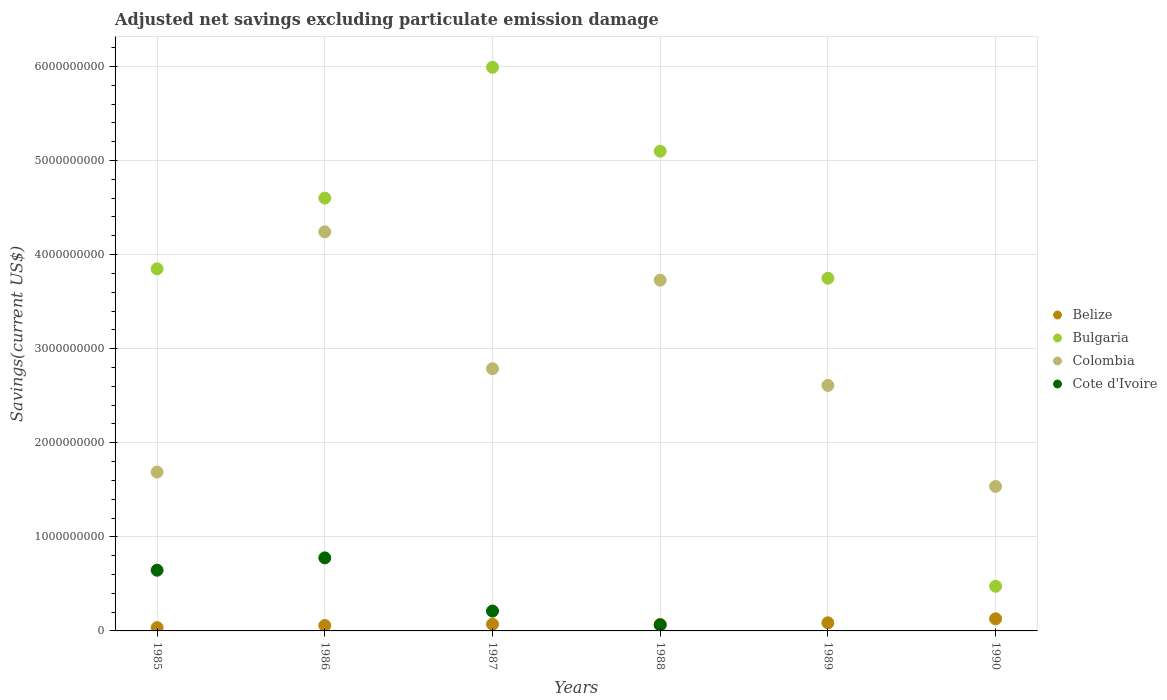How many different coloured dotlines are there?
Keep it short and to the point. 4. Is the number of dotlines equal to the number of legend labels?
Provide a short and direct response. No. What is the adjusted net savings in Belize in 1985?
Provide a succinct answer. 3.48e+07. Across all years, what is the maximum adjusted net savings in Belize?
Provide a short and direct response. 1.29e+08. Across all years, what is the minimum adjusted net savings in Colombia?
Make the answer very short. 1.54e+09. What is the total adjusted net savings in Bulgaria in the graph?
Make the answer very short. 2.38e+1. What is the difference between the adjusted net savings in Cote d'Ivoire in 1986 and that in 1988?
Offer a very short reply. 7.13e+08. What is the difference between the adjusted net savings in Cote d'Ivoire in 1985 and the adjusted net savings in Belize in 1987?
Offer a very short reply. 5.74e+08. What is the average adjusted net savings in Bulgaria per year?
Offer a very short reply. 3.96e+09. In the year 1987, what is the difference between the adjusted net savings in Colombia and adjusted net savings in Belize?
Your answer should be very brief. 2.72e+09. What is the ratio of the adjusted net savings in Belize in 1987 to that in 1989?
Your response must be concise. 0.83. Is the difference between the adjusted net savings in Colombia in 1987 and 1990 greater than the difference between the adjusted net savings in Belize in 1987 and 1990?
Give a very brief answer. Yes. What is the difference between the highest and the second highest adjusted net savings in Bulgaria?
Your response must be concise. 8.91e+08. What is the difference between the highest and the lowest adjusted net savings in Belize?
Provide a succinct answer. 9.39e+07. Is the sum of the adjusted net savings in Colombia in 1985 and 1987 greater than the maximum adjusted net savings in Bulgaria across all years?
Provide a succinct answer. No. Is it the case that in every year, the sum of the adjusted net savings in Colombia and adjusted net savings in Belize  is greater than the sum of adjusted net savings in Bulgaria and adjusted net savings in Cote d'Ivoire?
Offer a very short reply. Yes. Is the adjusted net savings in Cote d'Ivoire strictly greater than the adjusted net savings in Belize over the years?
Offer a very short reply. No. Is the adjusted net savings in Cote d'Ivoire strictly less than the adjusted net savings in Belize over the years?
Offer a very short reply. No. How many dotlines are there?
Offer a very short reply. 4. What is the difference between two consecutive major ticks on the Y-axis?
Make the answer very short. 1.00e+09. Are the values on the major ticks of Y-axis written in scientific E-notation?
Provide a succinct answer. No. Does the graph contain any zero values?
Keep it short and to the point. Yes. How are the legend labels stacked?
Ensure brevity in your answer.  Vertical. What is the title of the graph?
Make the answer very short. Adjusted net savings excluding particulate emission damage. What is the label or title of the X-axis?
Provide a short and direct response. Years. What is the label or title of the Y-axis?
Provide a succinct answer. Savings(current US$). What is the Savings(current US$) of Belize in 1985?
Provide a succinct answer. 3.48e+07. What is the Savings(current US$) of Bulgaria in 1985?
Keep it short and to the point. 3.85e+09. What is the Savings(current US$) of Colombia in 1985?
Provide a succinct answer. 1.69e+09. What is the Savings(current US$) in Cote d'Ivoire in 1985?
Ensure brevity in your answer.  6.45e+08. What is the Savings(current US$) of Belize in 1986?
Keep it short and to the point. 5.77e+07. What is the Savings(current US$) in Bulgaria in 1986?
Provide a succinct answer. 4.60e+09. What is the Savings(current US$) of Colombia in 1986?
Give a very brief answer. 4.24e+09. What is the Savings(current US$) of Cote d'Ivoire in 1986?
Offer a very short reply. 7.76e+08. What is the Savings(current US$) of Belize in 1987?
Make the answer very short. 7.15e+07. What is the Savings(current US$) in Bulgaria in 1987?
Keep it short and to the point. 5.99e+09. What is the Savings(current US$) of Colombia in 1987?
Keep it short and to the point. 2.79e+09. What is the Savings(current US$) of Cote d'Ivoire in 1987?
Ensure brevity in your answer.  2.11e+08. What is the Savings(current US$) in Belize in 1988?
Provide a short and direct response. 7.06e+07. What is the Savings(current US$) in Bulgaria in 1988?
Offer a very short reply. 5.10e+09. What is the Savings(current US$) in Colombia in 1988?
Provide a succinct answer. 3.73e+09. What is the Savings(current US$) of Cote d'Ivoire in 1988?
Offer a very short reply. 6.33e+07. What is the Savings(current US$) of Belize in 1989?
Your answer should be very brief. 8.63e+07. What is the Savings(current US$) in Bulgaria in 1989?
Keep it short and to the point. 3.75e+09. What is the Savings(current US$) in Colombia in 1989?
Your answer should be compact. 2.61e+09. What is the Savings(current US$) in Cote d'Ivoire in 1989?
Your answer should be compact. 0. What is the Savings(current US$) of Belize in 1990?
Give a very brief answer. 1.29e+08. What is the Savings(current US$) of Bulgaria in 1990?
Give a very brief answer. 4.74e+08. What is the Savings(current US$) in Colombia in 1990?
Keep it short and to the point. 1.54e+09. What is the Savings(current US$) of Cote d'Ivoire in 1990?
Make the answer very short. 0. Across all years, what is the maximum Savings(current US$) in Belize?
Ensure brevity in your answer.  1.29e+08. Across all years, what is the maximum Savings(current US$) of Bulgaria?
Your response must be concise. 5.99e+09. Across all years, what is the maximum Savings(current US$) in Colombia?
Provide a succinct answer. 4.24e+09. Across all years, what is the maximum Savings(current US$) in Cote d'Ivoire?
Ensure brevity in your answer.  7.76e+08. Across all years, what is the minimum Savings(current US$) of Belize?
Offer a terse response. 3.48e+07. Across all years, what is the minimum Savings(current US$) of Bulgaria?
Provide a succinct answer. 4.74e+08. Across all years, what is the minimum Savings(current US$) of Colombia?
Ensure brevity in your answer.  1.54e+09. What is the total Savings(current US$) in Belize in the graph?
Provide a succinct answer. 4.50e+08. What is the total Savings(current US$) of Bulgaria in the graph?
Give a very brief answer. 2.38e+1. What is the total Savings(current US$) in Colombia in the graph?
Provide a short and direct response. 1.66e+1. What is the total Savings(current US$) in Cote d'Ivoire in the graph?
Keep it short and to the point. 1.70e+09. What is the difference between the Savings(current US$) in Belize in 1985 and that in 1986?
Your response must be concise. -2.29e+07. What is the difference between the Savings(current US$) in Bulgaria in 1985 and that in 1986?
Offer a very short reply. -7.52e+08. What is the difference between the Savings(current US$) of Colombia in 1985 and that in 1986?
Your response must be concise. -2.55e+09. What is the difference between the Savings(current US$) in Cote d'Ivoire in 1985 and that in 1986?
Offer a very short reply. -1.31e+08. What is the difference between the Savings(current US$) in Belize in 1985 and that in 1987?
Offer a very short reply. -3.67e+07. What is the difference between the Savings(current US$) of Bulgaria in 1985 and that in 1987?
Your response must be concise. -2.14e+09. What is the difference between the Savings(current US$) in Colombia in 1985 and that in 1987?
Your answer should be very brief. -1.10e+09. What is the difference between the Savings(current US$) in Cote d'Ivoire in 1985 and that in 1987?
Offer a very short reply. 4.34e+08. What is the difference between the Savings(current US$) of Belize in 1985 and that in 1988?
Your answer should be very brief. -3.58e+07. What is the difference between the Savings(current US$) of Bulgaria in 1985 and that in 1988?
Offer a very short reply. -1.25e+09. What is the difference between the Savings(current US$) in Colombia in 1985 and that in 1988?
Your answer should be compact. -2.04e+09. What is the difference between the Savings(current US$) in Cote d'Ivoire in 1985 and that in 1988?
Your answer should be very brief. 5.82e+08. What is the difference between the Savings(current US$) in Belize in 1985 and that in 1989?
Make the answer very short. -5.16e+07. What is the difference between the Savings(current US$) of Bulgaria in 1985 and that in 1989?
Your response must be concise. 9.99e+07. What is the difference between the Savings(current US$) in Colombia in 1985 and that in 1989?
Provide a succinct answer. -9.21e+08. What is the difference between the Savings(current US$) in Belize in 1985 and that in 1990?
Offer a terse response. -9.39e+07. What is the difference between the Savings(current US$) of Bulgaria in 1985 and that in 1990?
Offer a very short reply. 3.37e+09. What is the difference between the Savings(current US$) of Colombia in 1985 and that in 1990?
Provide a succinct answer. 1.53e+08. What is the difference between the Savings(current US$) in Belize in 1986 and that in 1987?
Your answer should be very brief. -1.38e+07. What is the difference between the Savings(current US$) of Bulgaria in 1986 and that in 1987?
Ensure brevity in your answer.  -1.39e+09. What is the difference between the Savings(current US$) of Colombia in 1986 and that in 1987?
Provide a succinct answer. 1.46e+09. What is the difference between the Savings(current US$) of Cote d'Ivoire in 1986 and that in 1987?
Offer a terse response. 5.65e+08. What is the difference between the Savings(current US$) in Belize in 1986 and that in 1988?
Offer a terse response. -1.29e+07. What is the difference between the Savings(current US$) of Bulgaria in 1986 and that in 1988?
Provide a short and direct response. -4.99e+08. What is the difference between the Savings(current US$) of Colombia in 1986 and that in 1988?
Ensure brevity in your answer.  5.14e+08. What is the difference between the Savings(current US$) in Cote d'Ivoire in 1986 and that in 1988?
Your answer should be compact. 7.13e+08. What is the difference between the Savings(current US$) of Belize in 1986 and that in 1989?
Your answer should be compact. -2.87e+07. What is the difference between the Savings(current US$) of Bulgaria in 1986 and that in 1989?
Ensure brevity in your answer.  8.52e+08. What is the difference between the Savings(current US$) of Colombia in 1986 and that in 1989?
Provide a succinct answer. 1.63e+09. What is the difference between the Savings(current US$) in Belize in 1986 and that in 1990?
Keep it short and to the point. -7.10e+07. What is the difference between the Savings(current US$) in Bulgaria in 1986 and that in 1990?
Your answer should be very brief. 4.13e+09. What is the difference between the Savings(current US$) of Colombia in 1986 and that in 1990?
Your answer should be very brief. 2.71e+09. What is the difference between the Savings(current US$) of Belize in 1987 and that in 1988?
Your answer should be very brief. 8.86e+05. What is the difference between the Savings(current US$) of Bulgaria in 1987 and that in 1988?
Your answer should be very brief. 8.91e+08. What is the difference between the Savings(current US$) in Colombia in 1987 and that in 1988?
Ensure brevity in your answer.  -9.41e+08. What is the difference between the Savings(current US$) of Cote d'Ivoire in 1987 and that in 1988?
Ensure brevity in your answer.  1.48e+08. What is the difference between the Savings(current US$) in Belize in 1987 and that in 1989?
Make the answer very short. -1.49e+07. What is the difference between the Savings(current US$) of Bulgaria in 1987 and that in 1989?
Keep it short and to the point. 2.24e+09. What is the difference between the Savings(current US$) in Colombia in 1987 and that in 1989?
Your answer should be compact. 1.77e+08. What is the difference between the Savings(current US$) of Belize in 1987 and that in 1990?
Your answer should be compact. -5.72e+07. What is the difference between the Savings(current US$) in Bulgaria in 1987 and that in 1990?
Your response must be concise. 5.52e+09. What is the difference between the Savings(current US$) in Colombia in 1987 and that in 1990?
Your answer should be compact. 1.25e+09. What is the difference between the Savings(current US$) of Belize in 1988 and that in 1989?
Your response must be concise. -1.57e+07. What is the difference between the Savings(current US$) of Bulgaria in 1988 and that in 1989?
Give a very brief answer. 1.35e+09. What is the difference between the Savings(current US$) in Colombia in 1988 and that in 1989?
Your answer should be very brief. 1.12e+09. What is the difference between the Savings(current US$) in Belize in 1988 and that in 1990?
Give a very brief answer. -5.81e+07. What is the difference between the Savings(current US$) in Bulgaria in 1988 and that in 1990?
Provide a short and direct response. 4.62e+09. What is the difference between the Savings(current US$) in Colombia in 1988 and that in 1990?
Offer a very short reply. 2.19e+09. What is the difference between the Savings(current US$) in Belize in 1989 and that in 1990?
Your response must be concise. -4.23e+07. What is the difference between the Savings(current US$) of Bulgaria in 1989 and that in 1990?
Provide a succinct answer. 3.27e+09. What is the difference between the Savings(current US$) of Colombia in 1989 and that in 1990?
Make the answer very short. 1.07e+09. What is the difference between the Savings(current US$) of Belize in 1985 and the Savings(current US$) of Bulgaria in 1986?
Your response must be concise. -4.57e+09. What is the difference between the Savings(current US$) in Belize in 1985 and the Savings(current US$) in Colombia in 1986?
Provide a short and direct response. -4.21e+09. What is the difference between the Savings(current US$) in Belize in 1985 and the Savings(current US$) in Cote d'Ivoire in 1986?
Your answer should be compact. -7.42e+08. What is the difference between the Savings(current US$) of Bulgaria in 1985 and the Savings(current US$) of Colombia in 1986?
Offer a very short reply. -3.94e+08. What is the difference between the Savings(current US$) of Bulgaria in 1985 and the Savings(current US$) of Cote d'Ivoire in 1986?
Your answer should be compact. 3.07e+09. What is the difference between the Savings(current US$) of Colombia in 1985 and the Savings(current US$) of Cote d'Ivoire in 1986?
Give a very brief answer. 9.12e+08. What is the difference between the Savings(current US$) of Belize in 1985 and the Savings(current US$) of Bulgaria in 1987?
Keep it short and to the point. -5.96e+09. What is the difference between the Savings(current US$) of Belize in 1985 and the Savings(current US$) of Colombia in 1987?
Keep it short and to the point. -2.75e+09. What is the difference between the Savings(current US$) in Belize in 1985 and the Savings(current US$) in Cote d'Ivoire in 1987?
Offer a very short reply. -1.76e+08. What is the difference between the Savings(current US$) of Bulgaria in 1985 and the Savings(current US$) of Colombia in 1987?
Make the answer very short. 1.06e+09. What is the difference between the Savings(current US$) in Bulgaria in 1985 and the Savings(current US$) in Cote d'Ivoire in 1987?
Ensure brevity in your answer.  3.64e+09. What is the difference between the Savings(current US$) of Colombia in 1985 and the Savings(current US$) of Cote d'Ivoire in 1987?
Give a very brief answer. 1.48e+09. What is the difference between the Savings(current US$) in Belize in 1985 and the Savings(current US$) in Bulgaria in 1988?
Give a very brief answer. -5.06e+09. What is the difference between the Savings(current US$) of Belize in 1985 and the Savings(current US$) of Colombia in 1988?
Your answer should be very brief. -3.69e+09. What is the difference between the Savings(current US$) in Belize in 1985 and the Savings(current US$) in Cote d'Ivoire in 1988?
Your response must be concise. -2.86e+07. What is the difference between the Savings(current US$) of Bulgaria in 1985 and the Savings(current US$) of Colombia in 1988?
Your answer should be compact. 1.20e+08. What is the difference between the Savings(current US$) in Bulgaria in 1985 and the Savings(current US$) in Cote d'Ivoire in 1988?
Keep it short and to the point. 3.78e+09. What is the difference between the Savings(current US$) in Colombia in 1985 and the Savings(current US$) in Cote d'Ivoire in 1988?
Offer a terse response. 1.63e+09. What is the difference between the Savings(current US$) of Belize in 1985 and the Savings(current US$) of Bulgaria in 1989?
Your answer should be very brief. -3.71e+09. What is the difference between the Savings(current US$) in Belize in 1985 and the Savings(current US$) in Colombia in 1989?
Keep it short and to the point. -2.57e+09. What is the difference between the Savings(current US$) of Bulgaria in 1985 and the Savings(current US$) of Colombia in 1989?
Provide a short and direct response. 1.24e+09. What is the difference between the Savings(current US$) of Belize in 1985 and the Savings(current US$) of Bulgaria in 1990?
Provide a succinct answer. -4.40e+08. What is the difference between the Savings(current US$) in Belize in 1985 and the Savings(current US$) in Colombia in 1990?
Keep it short and to the point. -1.50e+09. What is the difference between the Savings(current US$) of Bulgaria in 1985 and the Savings(current US$) of Colombia in 1990?
Your response must be concise. 2.31e+09. What is the difference between the Savings(current US$) of Belize in 1986 and the Savings(current US$) of Bulgaria in 1987?
Keep it short and to the point. -5.93e+09. What is the difference between the Savings(current US$) of Belize in 1986 and the Savings(current US$) of Colombia in 1987?
Give a very brief answer. -2.73e+09. What is the difference between the Savings(current US$) in Belize in 1986 and the Savings(current US$) in Cote d'Ivoire in 1987?
Offer a terse response. -1.53e+08. What is the difference between the Savings(current US$) of Bulgaria in 1986 and the Savings(current US$) of Colombia in 1987?
Provide a succinct answer. 1.81e+09. What is the difference between the Savings(current US$) of Bulgaria in 1986 and the Savings(current US$) of Cote d'Ivoire in 1987?
Make the answer very short. 4.39e+09. What is the difference between the Savings(current US$) of Colombia in 1986 and the Savings(current US$) of Cote d'Ivoire in 1987?
Your answer should be compact. 4.03e+09. What is the difference between the Savings(current US$) in Belize in 1986 and the Savings(current US$) in Bulgaria in 1988?
Your answer should be very brief. -5.04e+09. What is the difference between the Savings(current US$) in Belize in 1986 and the Savings(current US$) in Colombia in 1988?
Give a very brief answer. -3.67e+09. What is the difference between the Savings(current US$) in Belize in 1986 and the Savings(current US$) in Cote d'Ivoire in 1988?
Your answer should be compact. -5.68e+06. What is the difference between the Savings(current US$) of Bulgaria in 1986 and the Savings(current US$) of Colombia in 1988?
Your answer should be very brief. 8.72e+08. What is the difference between the Savings(current US$) of Bulgaria in 1986 and the Savings(current US$) of Cote d'Ivoire in 1988?
Provide a succinct answer. 4.54e+09. What is the difference between the Savings(current US$) of Colombia in 1986 and the Savings(current US$) of Cote d'Ivoire in 1988?
Your response must be concise. 4.18e+09. What is the difference between the Savings(current US$) of Belize in 1986 and the Savings(current US$) of Bulgaria in 1989?
Give a very brief answer. -3.69e+09. What is the difference between the Savings(current US$) of Belize in 1986 and the Savings(current US$) of Colombia in 1989?
Offer a very short reply. -2.55e+09. What is the difference between the Savings(current US$) of Bulgaria in 1986 and the Savings(current US$) of Colombia in 1989?
Ensure brevity in your answer.  1.99e+09. What is the difference between the Savings(current US$) of Belize in 1986 and the Savings(current US$) of Bulgaria in 1990?
Give a very brief answer. -4.17e+08. What is the difference between the Savings(current US$) in Belize in 1986 and the Savings(current US$) in Colombia in 1990?
Your response must be concise. -1.48e+09. What is the difference between the Savings(current US$) in Bulgaria in 1986 and the Savings(current US$) in Colombia in 1990?
Offer a terse response. 3.06e+09. What is the difference between the Savings(current US$) of Belize in 1987 and the Savings(current US$) of Bulgaria in 1988?
Provide a short and direct response. -5.03e+09. What is the difference between the Savings(current US$) in Belize in 1987 and the Savings(current US$) in Colombia in 1988?
Provide a succinct answer. -3.66e+09. What is the difference between the Savings(current US$) of Belize in 1987 and the Savings(current US$) of Cote d'Ivoire in 1988?
Your answer should be compact. 8.15e+06. What is the difference between the Savings(current US$) of Bulgaria in 1987 and the Savings(current US$) of Colombia in 1988?
Ensure brevity in your answer.  2.26e+09. What is the difference between the Savings(current US$) of Bulgaria in 1987 and the Savings(current US$) of Cote d'Ivoire in 1988?
Give a very brief answer. 5.93e+09. What is the difference between the Savings(current US$) in Colombia in 1987 and the Savings(current US$) in Cote d'Ivoire in 1988?
Offer a very short reply. 2.72e+09. What is the difference between the Savings(current US$) of Belize in 1987 and the Savings(current US$) of Bulgaria in 1989?
Make the answer very short. -3.68e+09. What is the difference between the Savings(current US$) of Belize in 1987 and the Savings(current US$) of Colombia in 1989?
Offer a very short reply. -2.54e+09. What is the difference between the Savings(current US$) in Bulgaria in 1987 and the Savings(current US$) in Colombia in 1989?
Ensure brevity in your answer.  3.38e+09. What is the difference between the Savings(current US$) of Belize in 1987 and the Savings(current US$) of Bulgaria in 1990?
Your answer should be compact. -4.03e+08. What is the difference between the Savings(current US$) of Belize in 1987 and the Savings(current US$) of Colombia in 1990?
Ensure brevity in your answer.  -1.46e+09. What is the difference between the Savings(current US$) in Bulgaria in 1987 and the Savings(current US$) in Colombia in 1990?
Keep it short and to the point. 4.45e+09. What is the difference between the Savings(current US$) of Belize in 1988 and the Savings(current US$) of Bulgaria in 1989?
Your response must be concise. -3.68e+09. What is the difference between the Savings(current US$) of Belize in 1988 and the Savings(current US$) of Colombia in 1989?
Keep it short and to the point. -2.54e+09. What is the difference between the Savings(current US$) in Bulgaria in 1988 and the Savings(current US$) in Colombia in 1989?
Provide a succinct answer. 2.49e+09. What is the difference between the Savings(current US$) in Belize in 1988 and the Savings(current US$) in Bulgaria in 1990?
Offer a very short reply. -4.04e+08. What is the difference between the Savings(current US$) in Belize in 1988 and the Savings(current US$) in Colombia in 1990?
Offer a terse response. -1.46e+09. What is the difference between the Savings(current US$) in Bulgaria in 1988 and the Savings(current US$) in Colombia in 1990?
Make the answer very short. 3.56e+09. What is the difference between the Savings(current US$) in Belize in 1989 and the Savings(current US$) in Bulgaria in 1990?
Your answer should be compact. -3.88e+08. What is the difference between the Savings(current US$) in Belize in 1989 and the Savings(current US$) in Colombia in 1990?
Your answer should be very brief. -1.45e+09. What is the difference between the Savings(current US$) in Bulgaria in 1989 and the Savings(current US$) in Colombia in 1990?
Your answer should be compact. 2.21e+09. What is the average Savings(current US$) of Belize per year?
Provide a succinct answer. 7.49e+07. What is the average Savings(current US$) in Bulgaria per year?
Make the answer very short. 3.96e+09. What is the average Savings(current US$) in Colombia per year?
Give a very brief answer. 2.77e+09. What is the average Savings(current US$) in Cote d'Ivoire per year?
Your answer should be very brief. 2.83e+08. In the year 1985, what is the difference between the Savings(current US$) of Belize and Savings(current US$) of Bulgaria?
Provide a short and direct response. -3.81e+09. In the year 1985, what is the difference between the Savings(current US$) in Belize and Savings(current US$) in Colombia?
Provide a short and direct response. -1.65e+09. In the year 1985, what is the difference between the Savings(current US$) in Belize and Savings(current US$) in Cote d'Ivoire?
Give a very brief answer. -6.10e+08. In the year 1985, what is the difference between the Savings(current US$) in Bulgaria and Savings(current US$) in Colombia?
Offer a terse response. 2.16e+09. In the year 1985, what is the difference between the Savings(current US$) of Bulgaria and Savings(current US$) of Cote d'Ivoire?
Your response must be concise. 3.20e+09. In the year 1985, what is the difference between the Savings(current US$) of Colombia and Savings(current US$) of Cote d'Ivoire?
Provide a succinct answer. 1.04e+09. In the year 1986, what is the difference between the Savings(current US$) of Belize and Savings(current US$) of Bulgaria?
Make the answer very short. -4.54e+09. In the year 1986, what is the difference between the Savings(current US$) of Belize and Savings(current US$) of Colombia?
Provide a succinct answer. -4.18e+09. In the year 1986, what is the difference between the Savings(current US$) in Belize and Savings(current US$) in Cote d'Ivoire?
Your response must be concise. -7.19e+08. In the year 1986, what is the difference between the Savings(current US$) of Bulgaria and Savings(current US$) of Colombia?
Provide a short and direct response. 3.58e+08. In the year 1986, what is the difference between the Savings(current US$) of Bulgaria and Savings(current US$) of Cote d'Ivoire?
Your answer should be very brief. 3.82e+09. In the year 1986, what is the difference between the Savings(current US$) of Colombia and Savings(current US$) of Cote d'Ivoire?
Provide a succinct answer. 3.47e+09. In the year 1987, what is the difference between the Savings(current US$) in Belize and Savings(current US$) in Bulgaria?
Provide a short and direct response. -5.92e+09. In the year 1987, what is the difference between the Savings(current US$) of Belize and Savings(current US$) of Colombia?
Give a very brief answer. -2.72e+09. In the year 1987, what is the difference between the Savings(current US$) of Belize and Savings(current US$) of Cote d'Ivoire?
Ensure brevity in your answer.  -1.40e+08. In the year 1987, what is the difference between the Savings(current US$) of Bulgaria and Savings(current US$) of Colombia?
Offer a very short reply. 3.20e+09. In the year 1987, what is the difference between the Savings(current US$) in Bulgaria and Savings(current US$) in Cote d'Ivoire?
Offer a terse response. 5.78e+09. In the year 1987, what is the difference between the Savings(current US$) of Colombia and Savings(current US$) of Cote d'Ivoire?
Keep it short and to the point. 2.58e+09. In the year 1988, what is the difference between the Savings(current US$) in Belize and Savings(current US$) in Bulgaria?
Your answer should be very brief. -5.03e+09. In the year 1988, what is the difference between the Savings(current US$) of Belize and Savings(current US$) of Colombia?
Keep it short and to the point. -3.66e+09. In the year 1988, what is the difference between the Savings(current US$) of Belize and Savings(current US$) of Cote d'Ivoire?
Make the answer very short. 7.26e+06. In the year 1988, what is the difference between the Savings(current US$) of Bulgaria and Savings(current US$) of Colombia?
Make the answer very short. 1.37e+09. In the year 1988, what is the difference between the Savings(current US$) in Bulgaria and Savings(current US$) in Cote d'Ivoire?
Offer a terse response. 5.04e+09. In the year 1988, what is the difference between the Savings(current US$) in Colombia and Savings(current US$) in Cote d'Ivoire?
Keep it short and to the point. 3.66e+09. In the year 1989, what is the difference between the Savings(current US$) in Belize and Savings(current US$) in Bulgaria?
Offer a very short reply. -3.66e+09. In the year 1989, what is the difference between the Savings(current US$) in Belize and Savings(current US$) in Colombia?
Offer a very short reply. -2.52e+09. In the year 1989, what is the difference between the Savings(current US$) of Bulgaria and Savings(current US$) of Colombia?
Provide a short and direct response. 1.14e+09. In the year 1990, what is the difference between the Savings(current US$) in Belize and Savings(current US$) in Bulgaria?
Keep it short and to the point. -3.46e+08. In the year 1990, what is the difference between the Savings(current US$) of Belize and Savings(current US$) of Colombia?
Your response must be concise. -1.41e+09. In the year 1990, what is the difference between the Savings(current US$) of Bulgaria and Savings(current US$) of Colombia?
Your answer should be compact. -1.06e+09. What is the ratio of the Savings(current US$) in Belize in 1985 to that in 1986?
Offer a terse response. 0.6. What is the ratio of the Savings(current US$) in Bulgaria in 1985 to that in 1986?
Offer a terse response. 0.84. What is the ratio of the Savings(current US$) of Colombia in 1985 to that in 1986?
Your answer should be very brief. 0.4. What is the ratio of the Savings(current US$) in Cote d'Ivoire in 1985 to that in 1986?
Ensure brevity in your answer.  0.83. What is the ratio of the Savings(current US$) of Belize in 1985 to that in 1987?
Your response must be concise. 0.49. What is the ratio of the Savings(current US$) of Bulgaria in 1985 to that in 1987?
Keep it short and to the point. 0.64. What is the ratio of the Savings(current US$) of Colombia in 1985 to that in 1987?
Provide a succinct answer. 0.61. What is the ratio of the Savings(current US$) in Cote d'Ivoire in 1985 to that in 1987?
Ensure brevity in your answer.  3.06. What is the ratio of the Savings(current US$) of Belize in 1985 to that in 1988?
Keep it short and to the point. 0.49. What is the ratio of the Savings(current US$) in Bulgaria in 1985 to that in 1988?
Make the answer very short. 0.75. What is the ratio of the Savings(current US$) of Colombia in 1985 to that in 1988?
Provide a short and direct response. 0.45. What is the ratio of the Savings(current US$) in Cote d'Ivoire in 1985 to that in 1988?
Your answer should be compact. 10.18. What is the ratio of the Savings(current US$) in Belize in 1985 to that in 1989?
Ensure brevity in your answer.  0.4. What is the ratio of the Savings(current US$) of Bulgaria in 1985 to that in 1989?
Offer a terse response. 1.03. What is the ratio of the Savings(current US$) of Colombia in 1985 to that in 1989?
Offer a very short reply. 0.65. What is the ratio of the Savings(current US$) in Belize in 1985 to that in 1990?
Your answer should be compact. 0.27. What is the ratio of the Savings(current US$) in Bulgaria in 1985 to that in 1990?
Your response must be concise. 8.11. What is the ratio of the Savings(current US$) of Colombia in 1985 to that in 1990?
Keep it short and to the point. 1.1. What is the ratio of the Savings(current US$) in Belize in 1986 to that in 1987?
Your response must be concise. 0.81. What is the ratio of the Savings(current US$) in Bulgaria in 1986 to that in 1987?
Provide a succinct answer. 0.77. What is the ratio of the Savings(current US$) in Colombia in 1986 to that in 1987?
Keep it short and to the point. 1.52. What is the ratio of the Savings(current US$) of Cote d'Ivoire in 1986 to that in 1987?
Keep it short and to the point. 3.68. What is the ratio of the Savings(current US$) in Belize in 1986 to that in 1988?
Your response must be concise. 0.82. What is the ratio of the Savings(current US$) of Bulgaria in 1986 to that in 1988?
Provide a succinct answer. 0.9. What is the ratio of the Savings(current US$) in Colombia in 1986 to that in 1988?
Make the answer very short. 1.14. What is the ratio of the Savings(current US$) in Cote d'Ivoire in 1986 to that in 1988?
Provide a short and direct response. 12.26. What is the ratio of the Savings(current US$) of Belize in 1986 to that in 1989?
Offer a terse response. 0.67. What is the ratio of the Savings(current US$) in Bulgaria in 1986 to that in 1989?
Offer a terse response. 1.23. What is the ratio of the Savings(current US$) of Colombia in 1986 to that in 1989?
Provide a succinct answer. 1.63. What is the ratio of the Savings(current US$) of Belize in 1986 to that in 1990?
Keep it short and to the point. 0.45. What is the ratio of the Savings(current US$) in Bulgaria in 1986 to that in 1990?
Keep it short and to the point. 9.7. What is the ratio of the Savings(current US$) in Colombia in 1986 to that in 1990?
Make the answer very short. 2.76. What is the ratio of the Savings(current US$) in Belize in 1987 to that in 1988?
Your answer should be compact. 1.01. What is the ratio of the Savings(current US$) of Bulgaria in 1987 to that in 1988?
Provide a succinct answer. 1.17. What is the ratio of the Savings(current US$) of Colombia in 1987 to that in 1988?
Your answer should be very brief. 0.75. What is the ratio of the Savings(current US$) in Belize in 1987 to that in 1989?
Make the answer very short. 0.83. What is the ratio of the Savings(current US$) of Bulgaria in 1987 to that in 1989?
Ensure brevity in your answer.  1.6. What is the ratio of the Savings(current US$) in Colombia in 1987 to that in 1989?
Your answer should be very brief. 1.07. What is the ratio of the Savings(current US$) in Belize in 1987 to that in 1990?
Provide a short and direct response. 0.56. What is the ratio of the Savings(current US$) of Bulgaria in 1987 to that in 1990?
Offer a very short reply. 12.63. What is the ratio of the Savings(current US$) of Colombia in 1987 to that in 1990?
Your answer should be very brief. 1.81. What is the ratio of the Savings(current US$) of Belize in 1988 to that in 1989?
Provide a succinct answer. 0.82. What is the ratio of the Savings(current US$) of Bulgaria in 1988 to that in 1989?
Your response must be concise. 1.36. What is the ratio of the Savings(current US$) of Colombia in 1988 to that in 1989?
Offer a terse response. 1.43. What is the ratio of the Savings(current US$) in Belize in 1988 to that in 1990?
Offer a very short reply. 0.55. What is the ratio of the Savings(current US$) of Bulgaria in 1988 to that in 1990?
Your answer should be compact. 10.75. What is the ratio of the Savings(current US$) in Colombia in 1988 to that in 1990?
Provide a short and direct response. 2.43. What is the ratio of the Savings(current US$) of Belize in 1989 to that in 1990?
Provide a short and direct response. 0.67. What is the ratio of the Savings(current US$) of Bulgaria in 1989 to that in 1990?
Provide a succinct answer. 7.9. What is the ratio of the Savings(current US$) of Colombia in 1989 to that in 1990?
Give a very brief answer. 1.7. What is the difference between the highest and the second highest Savings(current US$) of Belize?
Ensure brevity in your answer.  4.23e+07. What is the difference between the highest and the second highest Savings(current US$) of Bulgaria?
Give a very brief answer. 8.91e+08. What is the difference between the highest and the second highest Savings(current US$) of Colombia?
Your answer should be very brief. 5.14e+08. What is the difference between the highest and the second highest Savings(current US$) of Cote d'Ivoire?
Give a very brief answer. 1.31e+08. What is the difference between the highest and the lowest Savings(current US$) of Belize?
Ensure brevity in your answer.  9.39e+07. What is the difference between the highest and the lowest Savings(current US$) in Bulgaria?
Your response must be concise. 5.52e+09. What is the difference between the highest and the lowest Savings(current US$) of Colombia?
Provide a succinct answer. 2.71e+09. What is the difference between the highest and the lowest Savings(current US$) in Cote d'Ivoire?
Ensure brevity in your answer.  7.76e+08. 